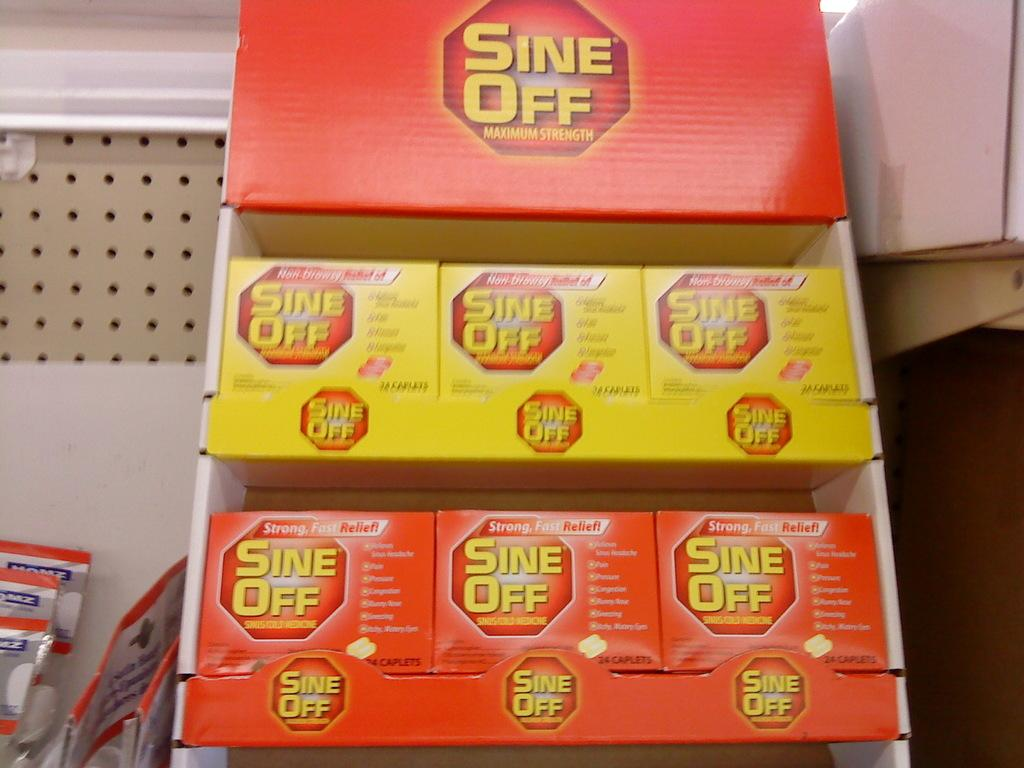<image>
Relay a brief, clear account of the picture shown. A container of Sine-Off Maximum Strength consists of multiple smaller packages. 